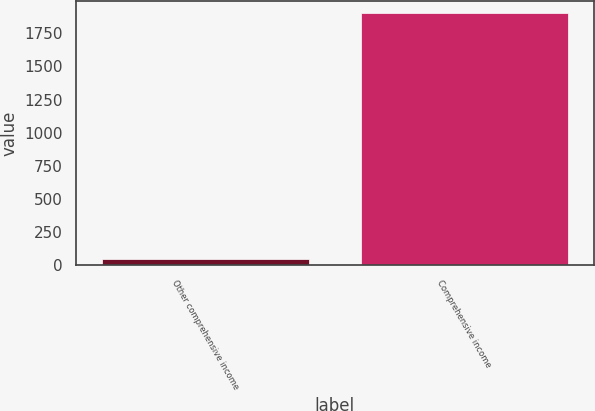Convert chart to OTSL. <chart><loc_0><loc_0><loc_500><loc_500><bar_chart><fcel>Other comprehensive income<fcel>Comprehensive income<nl><fcel>49.6<fcel>1900.8<nl></chart> 